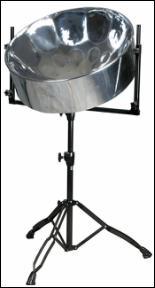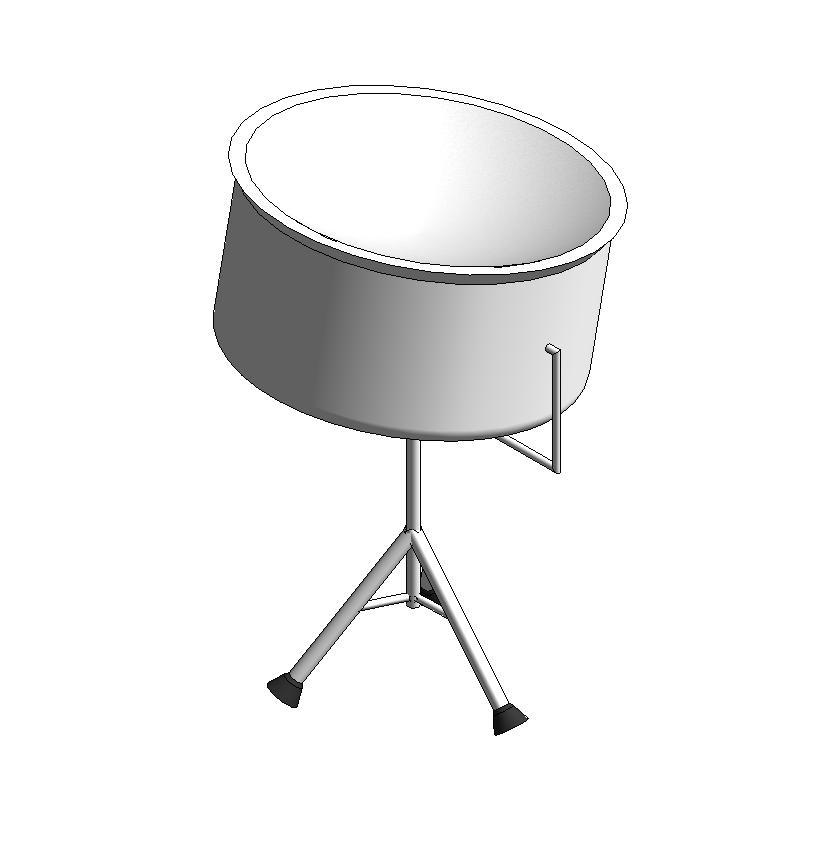The first image is the image on the left, the second image is the image on the right. Analyze the images presented: Is the assertion "Exactly two drums are attached to floor stands, which are different, but with the same style of feet." valid? Answer yes or no. Yes. The first image is the image on the left, the second image is the image on the right. For the images shown, is this caption "Each image shows one cylindrical metal drum with a concave top, and the drums on the right and left have similar shaped stands." true? Answer yes or no. Yes. 